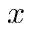<formula> <loc_0><loc_0><loc_500><loc_500>x</formula> 